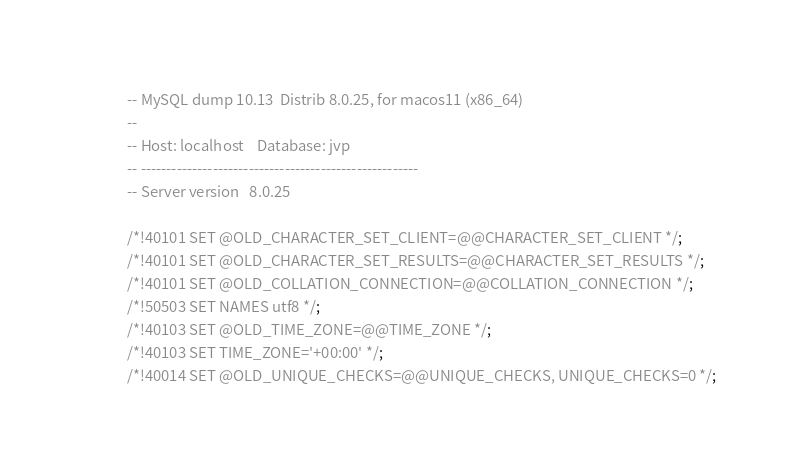Convert code to text. <code><loc_0><loc_0><loc_500><loc_500><_SQL_>-- MySQL dump 10.13  Distrib 8.0.25, for macos11 (x86_64)
--
-- Host: localhost    Database: jvp
-- ------------------------------------------------------
-- Server version	8.0.25

/*!40101 SET @OLD_CHARACTER_SET_CLIENT=@@CHARACTER_SET_CLIENT */;
/*!40101 SET @OLD_CHARACTER_SET_RESULTS=@@CHARACTER_SET_RESULTS */;
/*!40101 SET @OLD_COLLATION_CONNECTION=@@COLLATION_CONNECTION */;
/*!50503 SET NAMES utf8 */;
/*!40103 SET @OLD_TIME_ZONE=@@TIME_ZONE */;
/*!40103 SET TIME_ZONE='+00:00' */;
/*!40014 SET @OLD_UNIQUE_CHECKS=@@UNIQUE_CHECKS, UNIQUE_CHECKS=0 */;</code> 